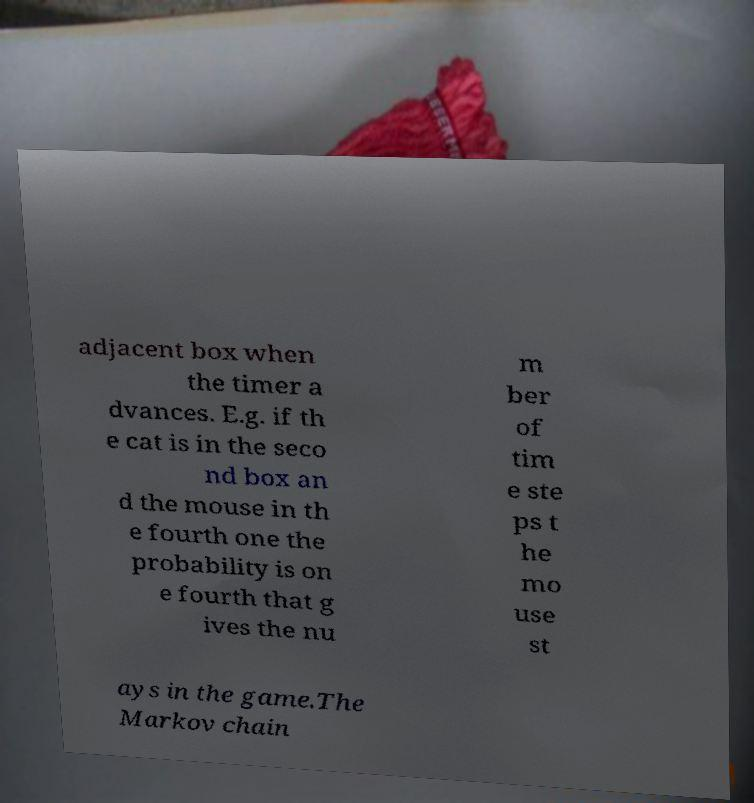For documentation purposes, I need the text within this image transcribed. Could you provide that? adjacent box when the timer a dvances. E.g. if th e cat is in the seco nd box an d the mouse in th e fourth one the probability is on e fourth that g ives the nu m ber of tim e ste ps t he mo use st ays in the game.The Markov chain 